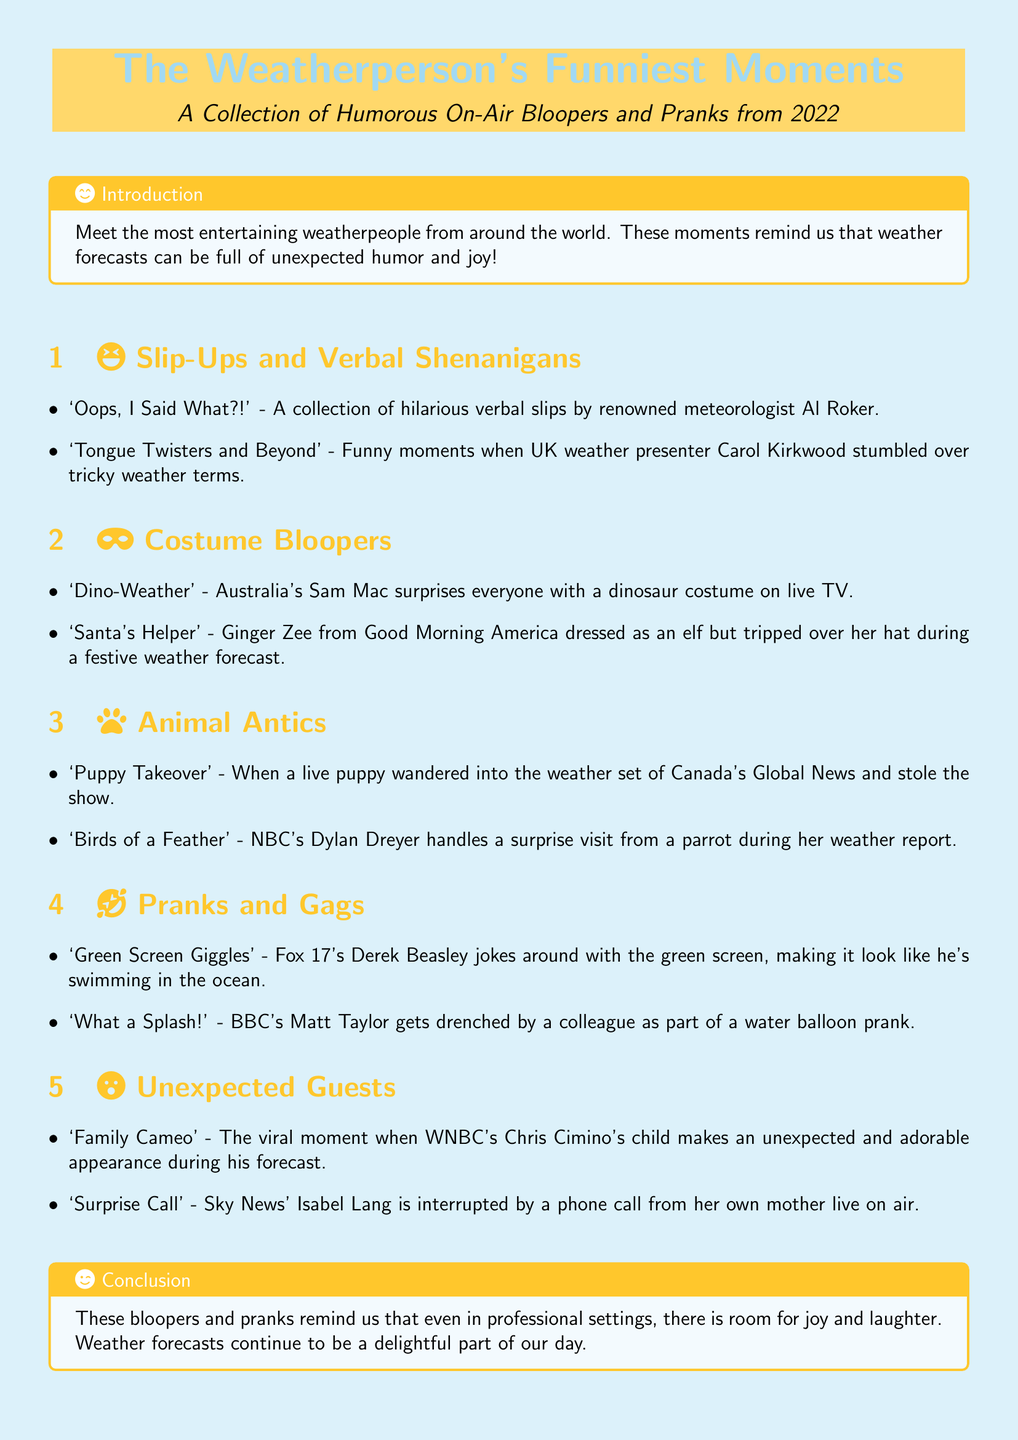what is the title of the document? The title is prominently displayed at the top of the document.
Answer: The Weatherperson's Funniest Moments who is the first weatherperson mentioned for slip-ups? The first weatherperson listed in the section covers verbal slip-ups.
Answer: Al Roker what type of costume did Sam Mac wear? The section on costume bloopers indicates this specific type of costume.
Answer: Dinosaur which animal interrupted Dylan Dreyer's weather report? The document mentions the specific animal that caused the disturbance during the report.
Answer: Parrot what prank involves a water balloon? This prank is categorized in the section about pranks and gags.
Answer: What a Splash! how many unexpected guest moments are listed? The index includes multiple instances under unexpected guests.
Answer: Two 